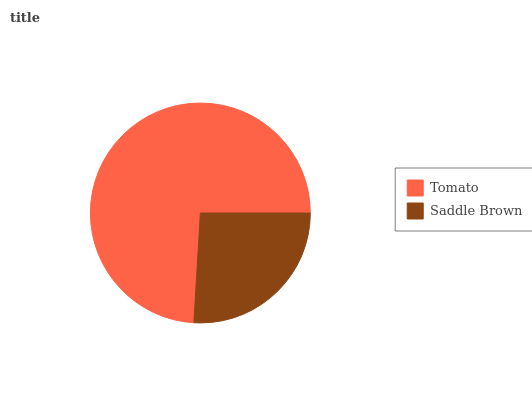Is Saddle Brown the minimum?
Answer yes or no. Yes. Is Tomato the maximum?
Answer yes or no. Yes. Is Saddle Brown the maximum?
Answer yes or no. No. Is Tomato greater than Saddle Brown?
Answer yes or no. Yes. Is Saddle Brown less than Tomato?
Answer yes or no. Yes. Is Saddle Brown greater than Tomato?
Answer yes or no. No. Is Tomato less than Saddle Brown?
Answer yes or no. No. Is Tomato the high median?
Answer yes or no. Yes. Is Saddle Brown the low median?
Answer yes or no. Yes. Is Saddle Brown the high median?
Answer yes or no. No. Is Tomato the low median?
Answer yes or no. No. 